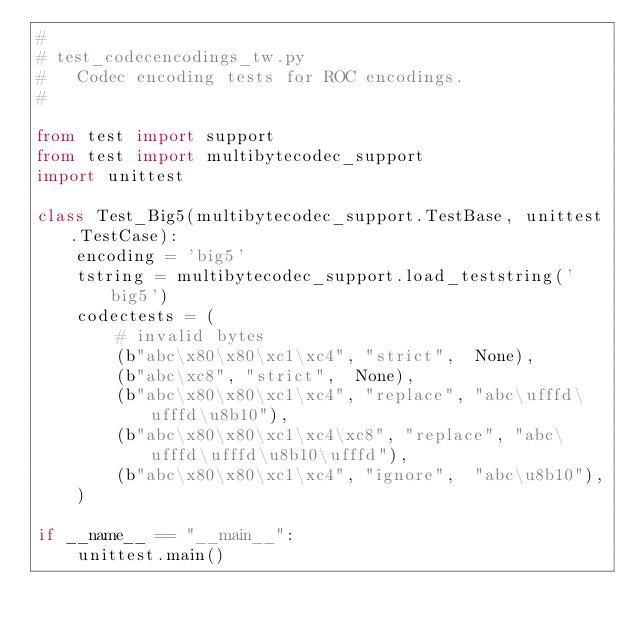<code> <loc_0><loc_0><loc_500><loc_500><_Python_>#
# test_codecencodings_tw.py
#   Codec encoding tests for ROC encodings.
#

from test import support
from test import multibytecodec_support
import unittest

class Test_Big5(multibytecodec_support.TestBase, unittest.TestCase):
    encoding = 'big5'
    tstring = multibytecodec_support.load_teststring('big5')
    codectests = (
        # invalid bytes
        (b"abc\x80\x80\xc1\xc4", "strict",  None),
        (b"abc\xc8", "strict",  None),
        (b"abc\x80\x80\xc1\xc4", "replace", "abc\ufffd\ufffd\u8b10"),
        (b"abc\x80\x80\xc1\xc4\xc8", "replace", "abc\ufffd\ufffd\u8b10\ufffd"),
        (b"abc\x80\x80\xc1\xc4", "ignore",  "abc\u8b10"),
    )

if __name__ == "__main__":
    unittest.main()
</code> 